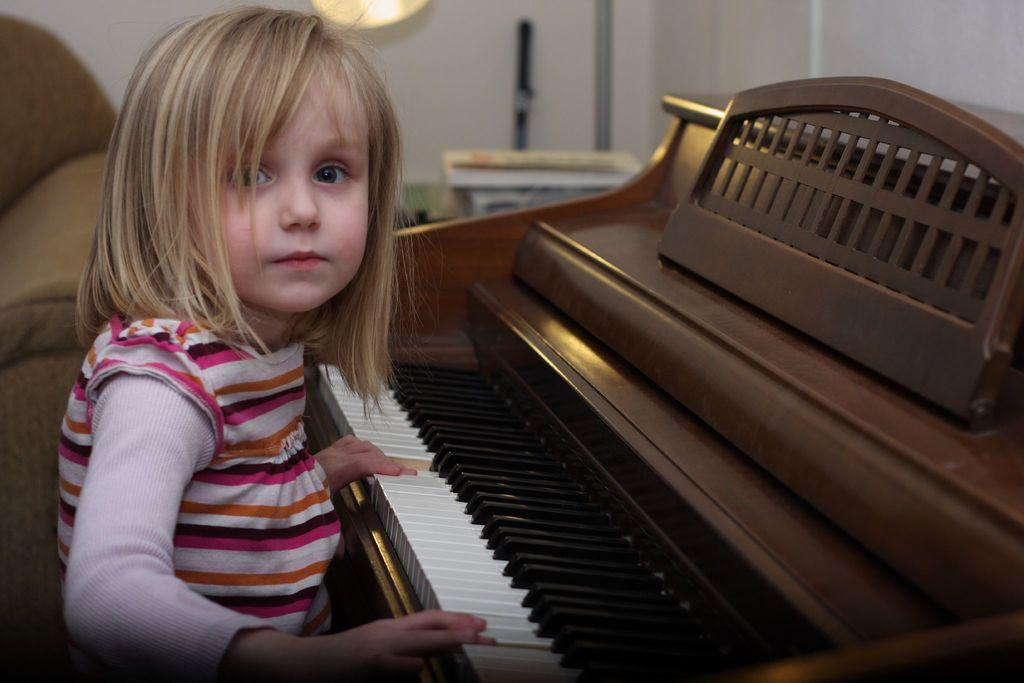Who is the main subject in the image? There is a little girl in the image. What is the girl doing in the image? The girl is playing a piano. Can you describe the position of the piano in relation to the girl? The piano is in front of the girl. What other piece of furniture is visible in the image? There is a couch beside the girl. What type of popcorn is the girl feeding to the donkey in the image? There is no donkey or popcorn present in the image. Can you tell me the color of the kitty sitting on the couch beside the girl? There is no kitty present in the image; only the girl, piano, and couch are visible. 